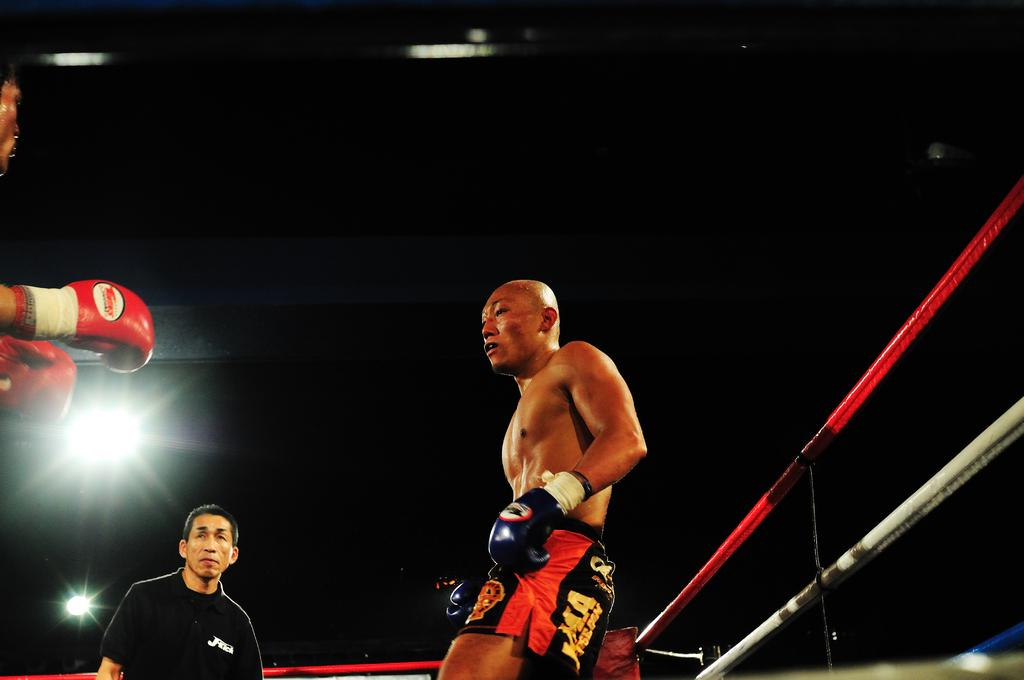<image>
Render a clear and concise summary of the photo. A boxer with the letter A on the side of his shorts looks tired. 